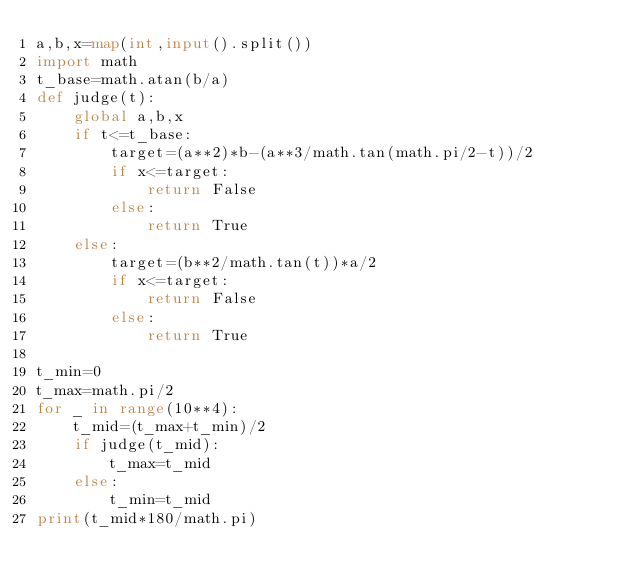<code> <loc_0><loc_0><loc_500><loc_500><_Python_>a,b,x=map(int,input().split())
import math
t_base=math.atan(b/a)
def judge(t):
    global a,b,x
    if t<=t_base:
        target=(a**2)*b-(a**3/math.tan(math.pi/2-t))/2
        if x<=target:
            return False
        else:
            return True
    else:
        target=(b**2/math.tan(t))*a/2
        if x<=target:
            return False
        else:
            return True

t_min=0
t_max=math.pi/2
for _ in range(10**4):
    t_mid=(t_max+t_min)/2
    if judge(t_mid):
        t_max=t_mid
    else:
        t_min=t_mid
print(t_mid*180/math.pi)</code> 